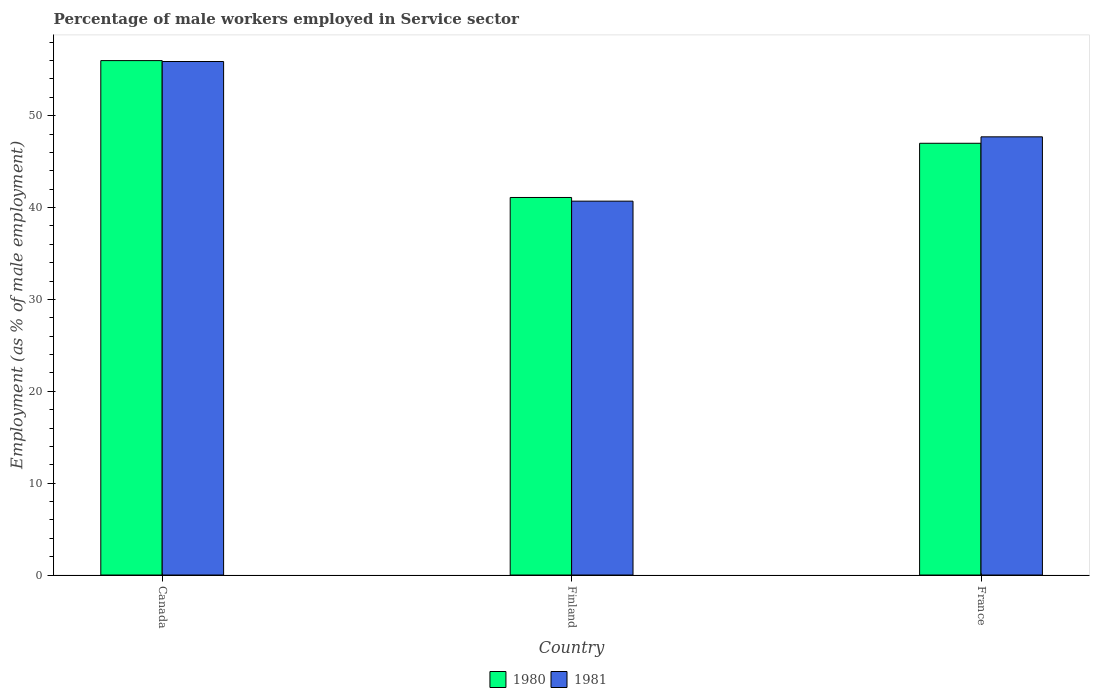How many different coloured bars are there?
Offer a terse response. 2. Are the number of bars on each tick of the X-axis equal?
Your response must be concise. Yes. How many bars are there on the 1st tick from the left?
Provide a short and direct response. 2. How many bars are there on the 3rd tick from the right?
Offer a terse response. 2. What is the label of the 1st group of bars from the left?
Your answer should be compact. Canada. In how many cases, is the number of bars for a given country not equal to the number of legend labels?
Your response must be concise. 0. What is the percentage of male workers employed in Service sector in 1981 in Canada?
Your answer should be compact. 55.9. Across all countries, what is the maximum percentage of male workers employed in Service sector in 1981?
Offer a terse response. 55.9. Across all countries, what is the minimum percentage of male workers employed in Service sector in 1981?
Provide a succinct answer. 40.7. What is the total percentage of male workers employed in Service sector in 1980 in the graph?
Make the answer very short. 144.1. What is the difference between the percentage of male workers employed in Service sector in 1980 in Canada and that in France?
Offer a very short reply. 9. What is the difference between the percentage of male workers employed in Service sector in 1981 in France and the percentage of male workers employed in Service sector in 1980 in Finland?
Make the answer very short. 6.6. What is the average percentage of male workers employed in Service sector in 1981 per country?
Provide a succinct answer. 48.1. What is the difference between the percentage of male workers employed in Service sector of/in 1981 and percentage of male workers employed in Service sector of/in 1980 in France?
Provide a short and direct response. 0.7. What is the ratio of the percentage of male workers employed in Service sector in 1980 in Canada to that in France?
Your answer should be compact. 1.19. What is the difference between the highest and the second highest percentage of male workers employed in Service sector in 1980?
Offer a very short reply. 14.9. What is the difference between the highest and the lowest percentage of male workers employed in Service sector in 1981?
Your answer should be very brief. 15.2. Is the sum of the percentage of male workers employed in Service sector in 1981 in Canada and Finland greater than the maximum percentage of male workers employed in Service sector in 1980 across all countries?
Ensure brevity in your answer.  Yes. What does the 2nd bar from the left in France represents?
Your response must be concise. 1981. Are all the bars in the graph horizontal?
Make the answer very short. No. How many countries are there in the graph?
Your response must be concise. 3. Does the graph contain grids?
Offer a terse response. No. How are the legend labels stacked?
Your answer should be compact. Horizontal. What is the title of the graph?
Ensure brevity in your answer.  Percentage of male workers employed in Service sector. Does "1998" appear as one of the legend labels in the graph?
Your answer should be compact. No. What is the label or title of the X-axis?
Your response must be concise. Country. What is the label or title of the Y-axis?
Your answer should be very brief. Employment (as % of male employment). What is the Employment (as % of male employment) in 1980 in Canada?
Provide a short and direct response. 56. What is the Employment (as % of male employment) of 1981 in Canada?
Offer a very short reply. 55.9. What is the Employment (as % of male employment) of 1980 in Finland?
Your answer should be very brief. 41.1. What is the Employment (as % of male employment) in 1981 in Finland?
Your response must be concise. 40.7. What is the Employment (as % of male employment) of 1980 in France?
Your response must be concise. 47. What is the Employment (as % of male employment) of 1981 in France?
Make the answer very short. 47.7. Across all countries, what is the maximum Employment (as % of male employment) of 1981?
Keep it short and to the point. 55.9. Across all countries, what is the minimum Employment (as % of male employment) in 1980?
Your answer should be compact. 41.1. Across all countries, what is the minimum Employment (as % of male employment) of 1981?
Your answer should be very brief. 40.7. What is the total Employment (as % of male employment) in 1980 in the graph?
Make the answer very short. 144.1. What is the total Employment (as % of male employment) in 1981 in the graph?
Offer a terse response. 144.3. What is the difference between the Employment (as % of male employment) in 1981 in Canada and that in Finland?
Provide a short and direct response. 15.2. What is the difference between the Employment (as % of male employment) in 1980 in Canada and that in France?
Give a very brief answer. 9. What is the difference between the Employment (as % of male employment) of 1980 in Finland and that in France?
Make the answer very short. -5.9. What is the difference between the Employment (as % of male employment) in 1980 in Canada and the Employment (as % of male employment) in 1981 in Finland?
Your response must be concise. 15.3. What is the difference between the Employment (as % of male employment) of 1980 in Canada and the Employment (as % of male employment) of 1981 in France?
Your answer should be very brief. 8.3. What is the average Employment (as % of male employment) in 1980 per country?
Your answer should be very brief. 48.03. What is the average Employment (as % of male employment) of 1981 per country?
Provide a short and direct response. 48.1. What is the difference between the Employment (as % of male employment) of 1980 and Employment (as % of male employment) of 1981 in Finland?
Offer a very short reply. 0.4. What is the ratio of the Employment (as % of male employment) in 1980 in Canada to that in Finland?
Your answer should be very brief. 1.36. What is the ratio of the Employment (as % of male employment) of 1981 in Canada to that in Finland?
Ensure brevity in your answer.  1.37. What is the ratio of the Employment (as % of male employment) in 1980 in Canada to that in France?
Offer a terse response. 1.19. What is the ratio of the Employment (as % of male employment) in 1981 in Canada to that in France?
Keep it short and to the point. 1.17. What is the ratio of the Employment (as % of male employment) of 1980 in Finland to that in France?
Provide a short and direct response. 0.87. What is the ratio of the Employment (as % of male employment) of 1981 in Finland to that in France?
Your response must be concise. 0.85. What is the difference between the highest and the second highest Employment (as % of male employment) of 1980?
Your answer should be compact. 9. What is the difference between the highest and the second highest Employment (as % of male employment) of 1981?
Give a very brief answer. 8.2. What is the difference between the highest and the lowest Employment (as % of male employment) of 1980?
Offer a very short reply. 14.9. 